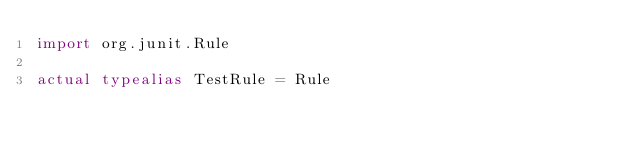Convert code to text. <code><loc_0><loc_0><loc_500><loc_500><_Kotlin_>import org.junit.Rule

actual typealias TestRule = Rule
</code> 